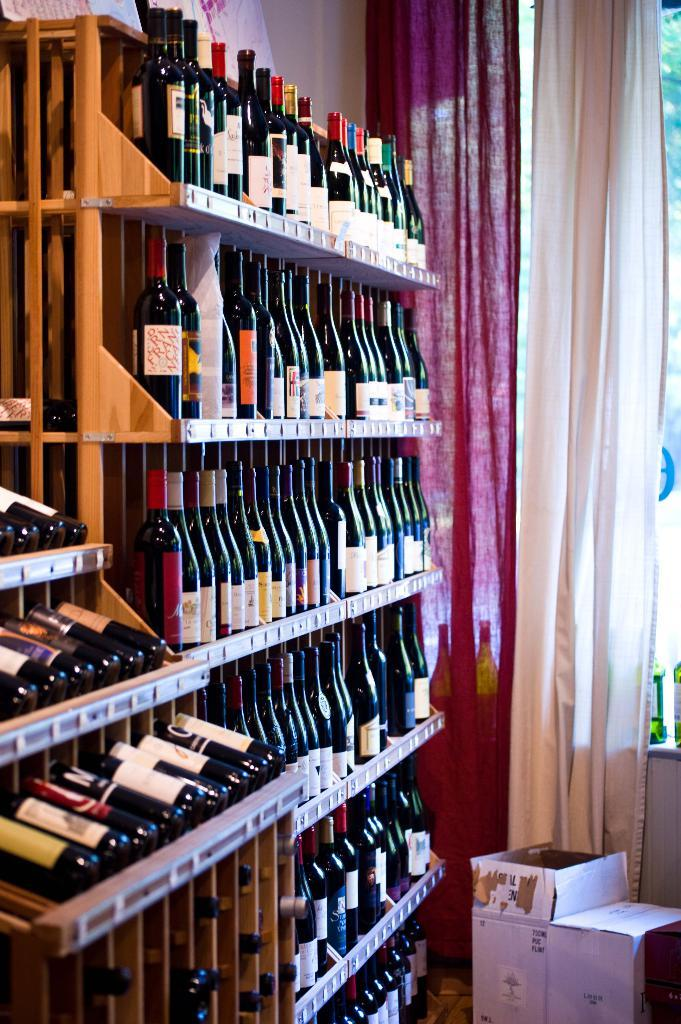What type of beverage containers are in the racks in the image? There are wine bottles in the racks in the image. What can be seen in the bottom right corner of the image? Cardboard boxes are visible in the bottom right corner of the image. What is behind the curtains in the image? There is a window behind the curtains in the image. What type of fabric is used to make the monkey's clothing in the image? There is no monkey present in the image, so it is not possible to determine the type of fabric used for its clothing. 